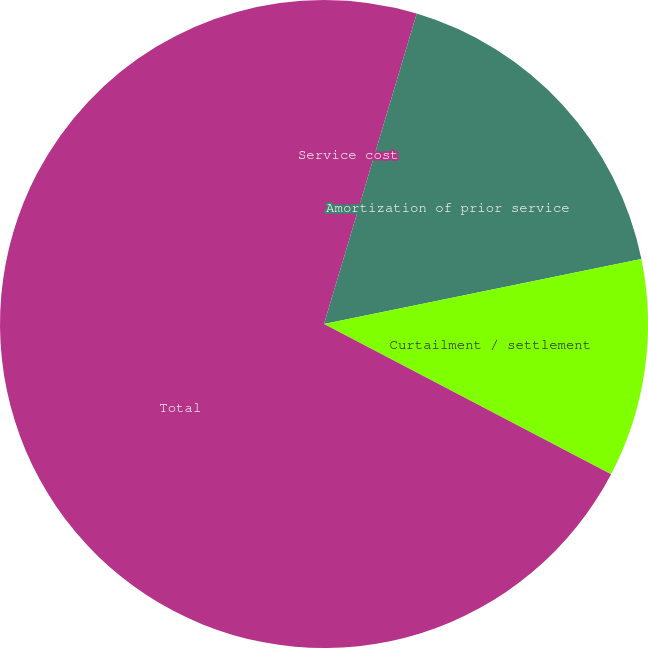<chart> <loc_0><loc_0><loc_500><loc_500><pie_chart><fcel>Service cost<fcel>Amortization of prior service<fcel>Curtailment / settlement<fcel>Total<nl><fcel>4.62%<fcel>17.16%<fcel>10.89%<fcel>67.33%<nl></chart> 